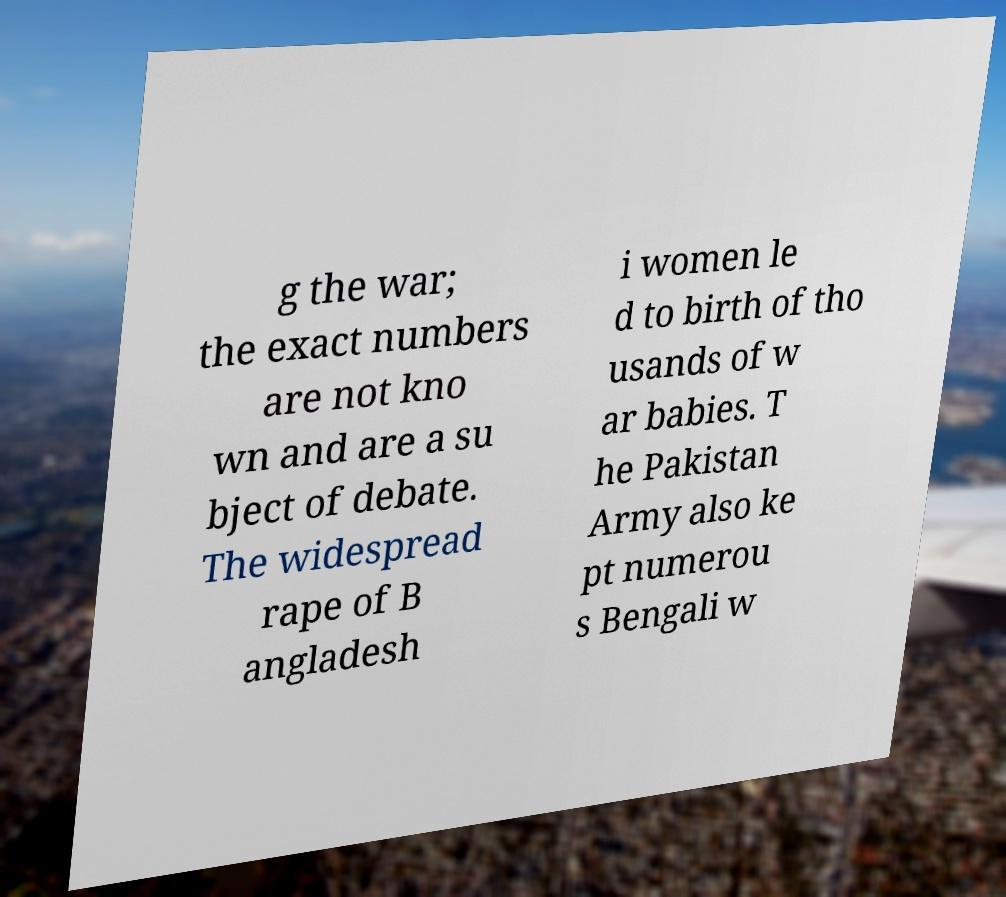For documentation purposes, I need the text within this image transcribed. Could you provide that? g the war; the exact numbers are not kno wn and are a su bject of debate. The widespread rape of B angladesh i women le d to birth of tho usands of w ar babies. T he Pakistan Army also ke pt numerou s Bengali w 